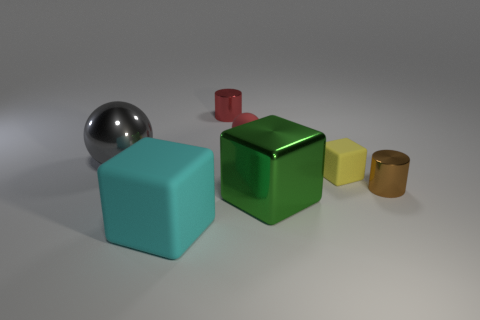Add 1 big red rubber spheres. How many objects exist? 8 Subtract all spheres. How many objects are left? 5 Add 5 tiny yellow matte things. How many tiny yellow matte things exist? 6 Subtract 0 green spheres. How many objects are left? 7 Subtract all big cyan matte objects. Subtract all tiny red metal things. How many objects are left? 5 Add 5 tiny brown cylinders. How many tiny brown cylinders are left? 6 